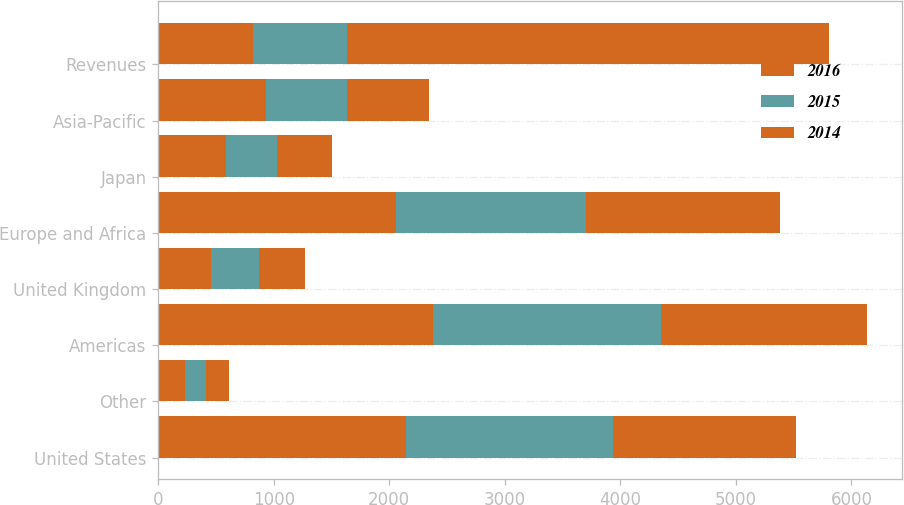Convert chart. <chart><loc_0><loc_0><loc_500><loc_500><stacked_bar_chart><ecel><fcel>United States<fcel>Other<fcel>Americas<fcel>United Kingdom<fcel>Europe and Africa<fcel>Japan<fcel>Asia-Pacific<fcel>Revenues<nl><fcel>2016<fcel>2145<fcel>233<fcel>2378<fcel>461<fcel>2055<fcel>587<fcel>931<fcel>818.5<nl><fcel>2015<fcel>1788<fcel>185<fcel>1973<fcel>410<fcel>1647<fcel>443<fcel>706<fcel>818.5<nl><fcel>2014<fcel>1589<fcel>195<fcel>1784<fcel>402<fcel>1677<fcel>472<fcel>704<fcel>4165<nl></chart> 